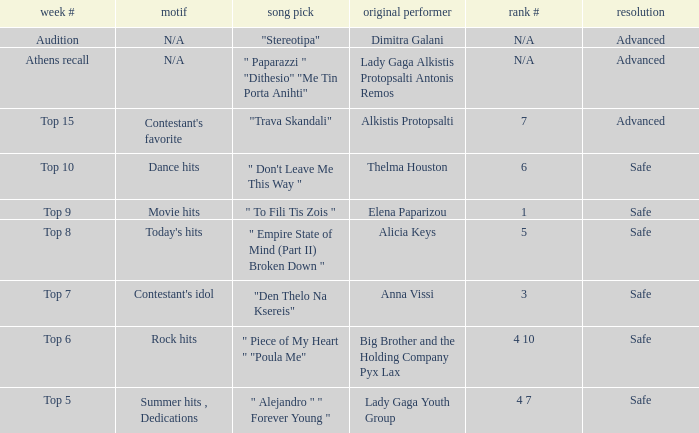Which week had the song choice " empire state of mind (part ii) broken down "? Top 8. 